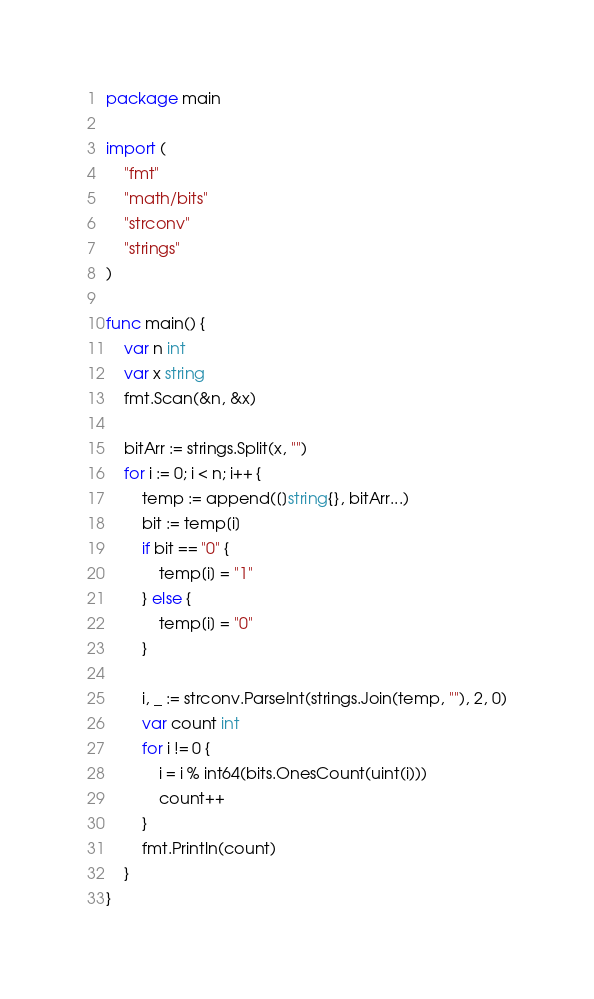Convert code to text. <code><loc_0><loc_0><loc_500><loc_500><_Go_>package main

import (
	"fmt"
	"math/bits"
	"strconv"
	"strings"
)

func main() {
	var n int
	var x string
	fmt.Scan(&n, &x)

	bitArr := strings.Split(x, "")
	for i := 0; i < n; i++ {
		temp := append([]string{}, bitArr...)
		bit := temp[i]
		if bit == "0" {
			temp[i] = "1"
		} else {
			temp[i] = "0"
		}

		i, _ := strconv.ParseInt(strings.Join(temp, ""), 2, 0)
		var count int
		for i != 0 {
			i = i % int64(bits.OnesCount(uint(i)))
			count++
		}
		fmt.Println(count)
	}
}
</code> 